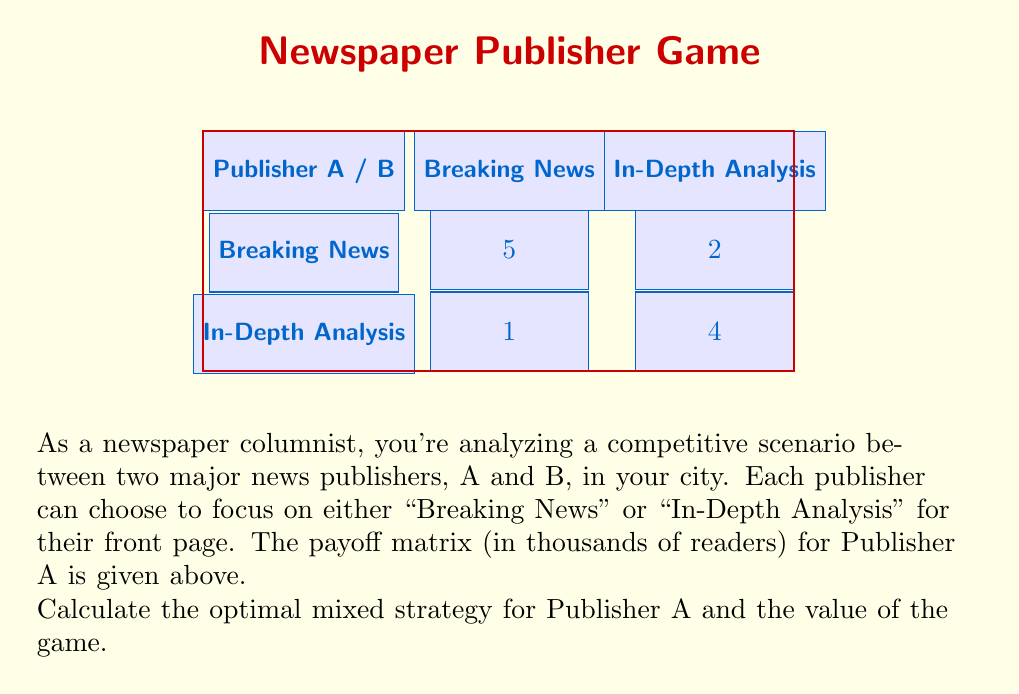Help me with this question. Let's solve this step-by-step using the principles of game theory:

1) Let $p$ be the probability that Publisher A chooses "Breaking News", and $(1-p)$ the probability of choosing "In-Depth Analysis".

2) For a mixed strategy to be optimal, the expected payoff for Publisher B should be the same regardless of their choice. We can express this as an equation:

   $$5p + 1(1-p) = 2p + 4(1-p)$$

3) Simplify the equation:
   $$5p + 1 - p = 2p + 4 - 4p$$
   $$4p + 1 = -2p + 4$$

4) Solve for $p$:
   $$6p = 3$$
   $$p = \frac{1}{2} = 0.5$$

5) This means Publisher A should choose "Breaking News" 50% of the time and "In-Depth Analysis" 50% of the time.

6) To find the value of the game (V), we can substitute $p = 0.5$ into either side of the equation from step 2:

   $$V = 5(0.5) + 1(0.5) = 2.5 + 0.5 = 3$$

Therefore, the value of the game is 3 thousand readers.
Answer: Optimal strategy: (0.5, 0.5); Game value: 3 